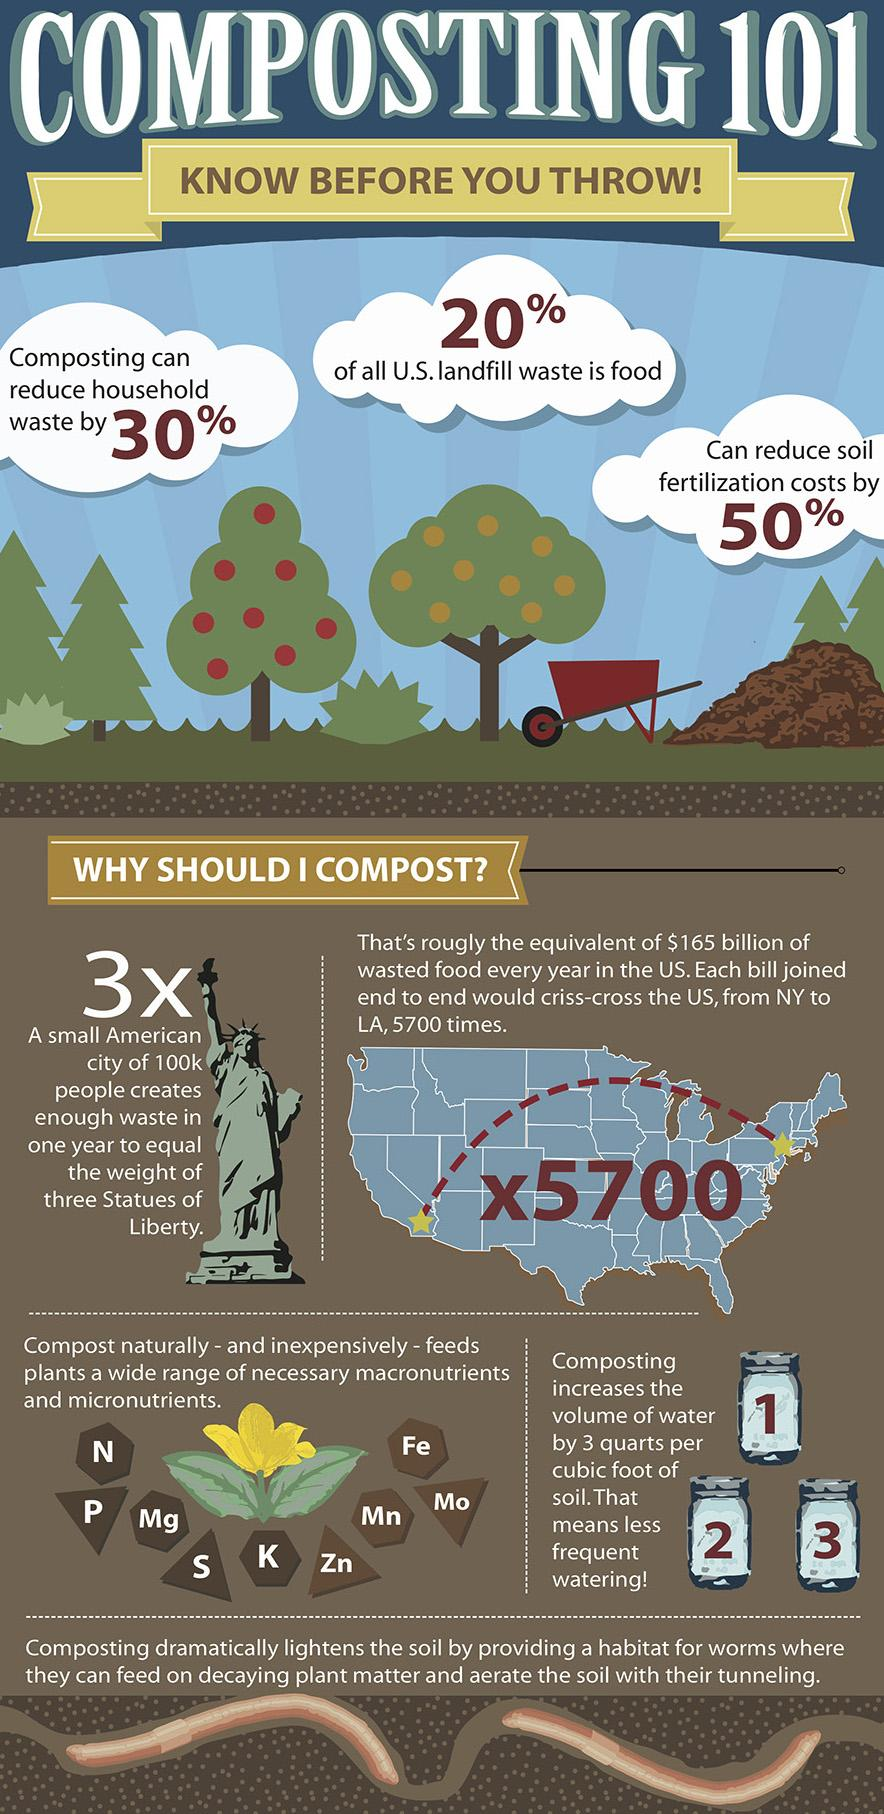Mention a couple of crucial points in this snapshot. Composting reduces soil propagation expenses by 50%. The second micro nutrient listed in the infographic is fiber The expected reduction in waste through composting is approximately 30%. 